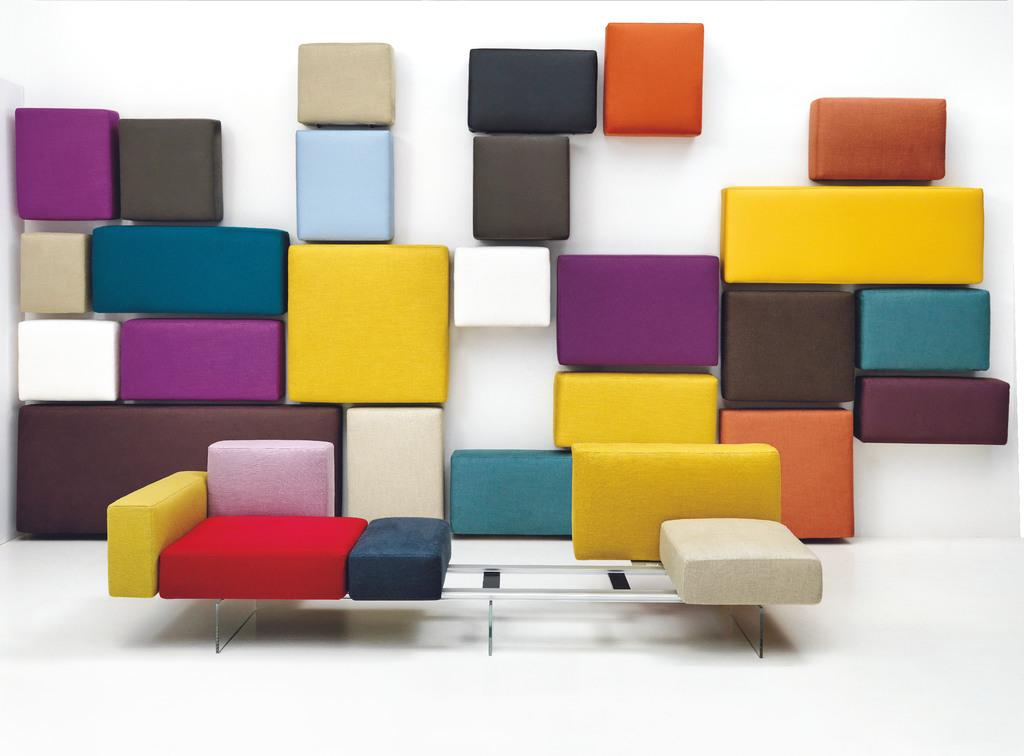What objects are present in the image? There are boxes in the image. How are the boxes arranged in the image? The boxes are arranged in random rows. What type of jeans can be seen in the image? There are no jeans present in the image; it only features boxes arranged in random rows. 